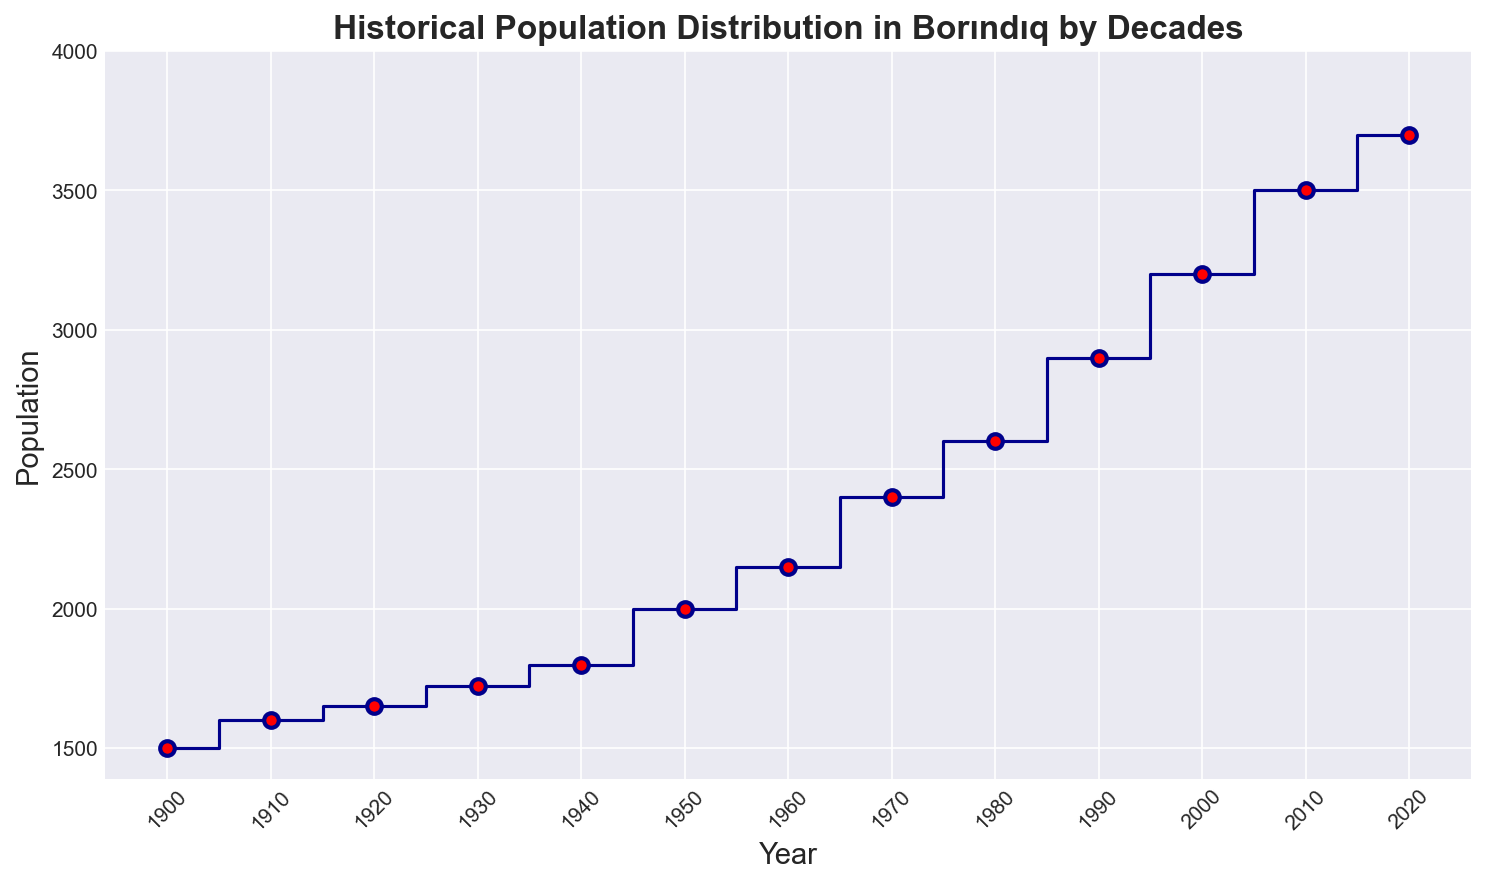What is the population of Borındıq in the year 2000? Referring to the figure, locate the data point that corresponds to the year 2000 on the x-axis and note the value on the y-axis.
Answer: 3200 What is the difference in population between the years 1910 and 1950? Locate the population values for the years 1910 (1600) and 1950 (2000) on the figure. Subtract the population of 1910 from the population of 1950: 2000 - 1600.
Answer: 400 Which decade saw the highest growth in population? Determine the population differences between each decade by subtracting the earlier year's population from the later year's population, then compare these differences to identify the largest one. The decade from 1980 to 1990 saw a growth from 2600 to 2900 which is 300, being the highest.
Answer: 1980-1990 By how much did the population increase from 1900 to 2020? Find the population values for the years 1900 (1500) and 2020 (3700). Subtract the population of 1900 from the population of 2020: 3700 - 1500.
Answer: 2200 What is the average population over the entire period? Sum the population values for all given decades and divide by the number of decades: (1500 + 1600 + 1650 + 1725 + 1800 + 2000 + 2150 + 2400 + 2600 + 2900 + 3200 + 3500 + 3700) / 13.
Answer: 2425 Describe the color of the markers on the figure. Observe the graphical markers on the figure and describe their color. The markers are red as indicated in the figure description.
Answer: Red Which year had a population closest to 2500? Look at the population values and identify which year has the closest population to 2500. In this case, the population in 1980 was 2600, which is the closest to 2500.
Answer: 1980 Was there any decade when the population decreased? Examine the figure to see if any decade shows a reduction in population from one year to the next. All recorded decades show an increase in population.
Answer: No How many years had a population greater than 3000? Identify the years on the x-axis with corresponding population values greater than 3000. This includes 2010 (3500) and 2020 (3700), so there are 2 instances.
Answer: 2 